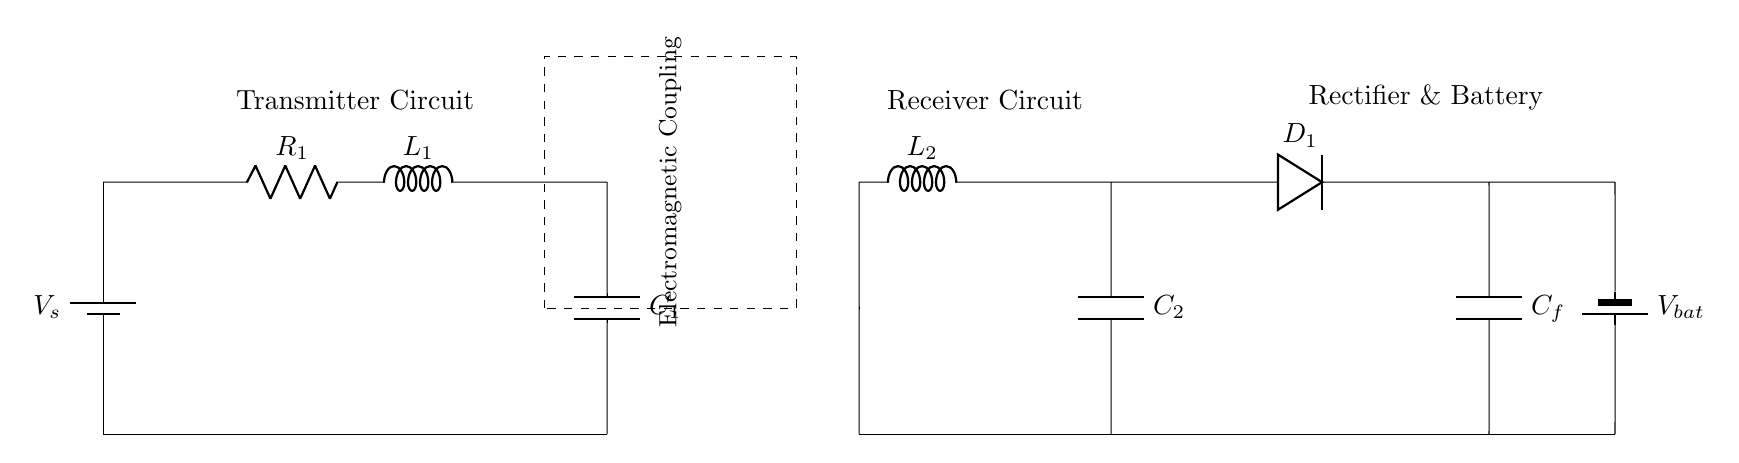What type of circuit is this? This is a wireless inductive charging circuit for smartphones, which uses electromagnetic coupling. The presence of components like inductors, capacitors, and a rectifier suggests that it is designed for transmitting and receiving energy wirelessly.
Answer: wireless inductive charging circuit What does R1 represent? R1 represents a resistor in the transmitter circuit. It is used to limit current and provide a stable operating condition for other components in the circuit.
Answer: resistor What is the purpose of the dashed rectangle? The dashed rectangle indicates the area of electromagnetic coupling between the transmitter and receiver circuits. It visually distinguishes the coupling region where energy transfer occurs without physical connections.
Answer: electromagnetic coupling Which component rectifies the output in the circuit? The rectifier component in the circuit is D1, which converts the alternating current (AC) generated in the receiver circuit into direct current (DC) suitable for charging the battery.
Answer: D1 How many capacitors are in the circuit? There are a total of three capacitors in the circuit: C1 in the transmitter circuit, C2 in the receiver circuit, and Cf in the rectifier and battery section. This plays a crucial role in the energy storage and filtering.
Answer: three What is the battery voltage labeled as? The voltage of the battery in this circuit is labeled as Vbat, indicating the potential difference across the battery which stores the energy received from the inductive coupling.
Answer: Vbat What is the role of L2 in this circuit? L2 serves as an inductor in the receiver circuit, which is part of the resonant circuit that enhances the efficiency of energy transfer from the transmitter to the receiver through electromagnetic coupling.
Answer: inductor 